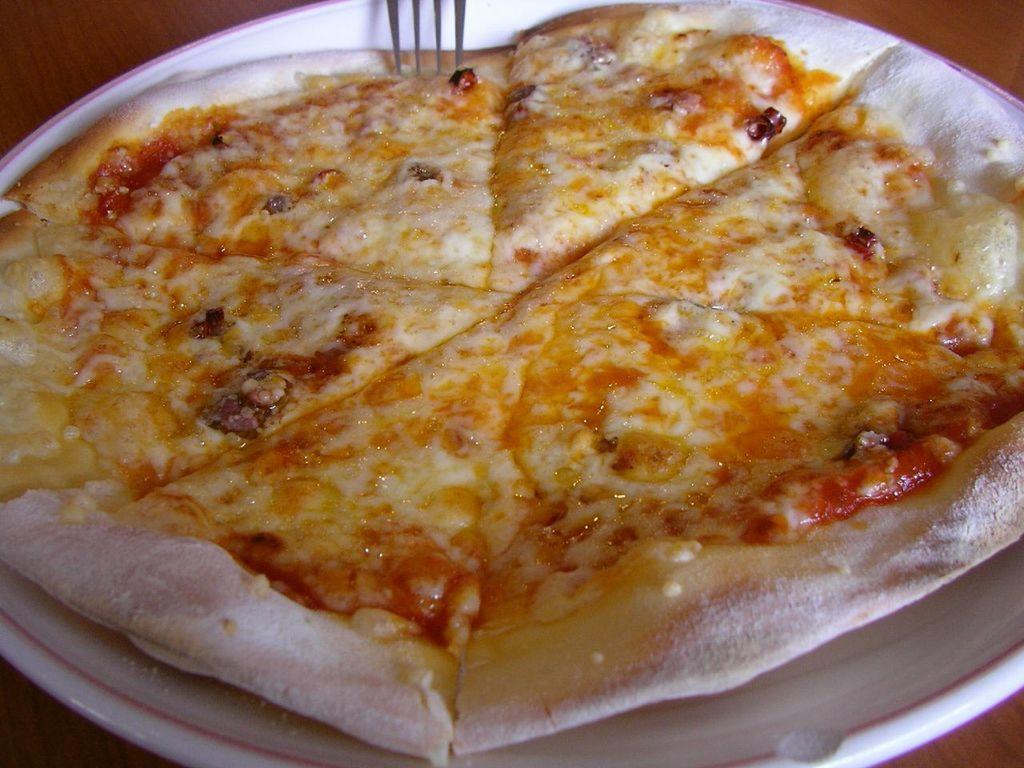How would you summarize this image in a sentence or two? In this image, we can see some food on the plate and we can see a fork. 